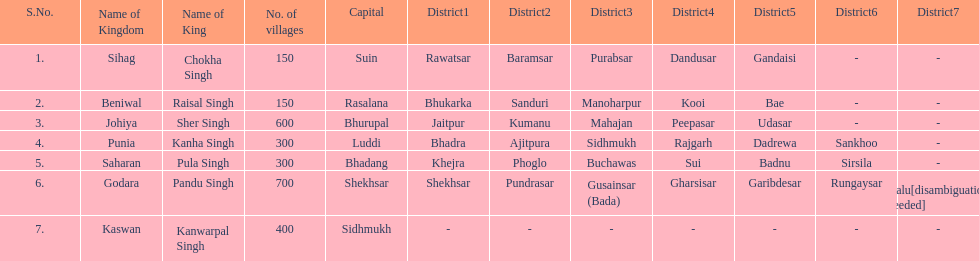What was the total number of districts within the state of godara? 7. 